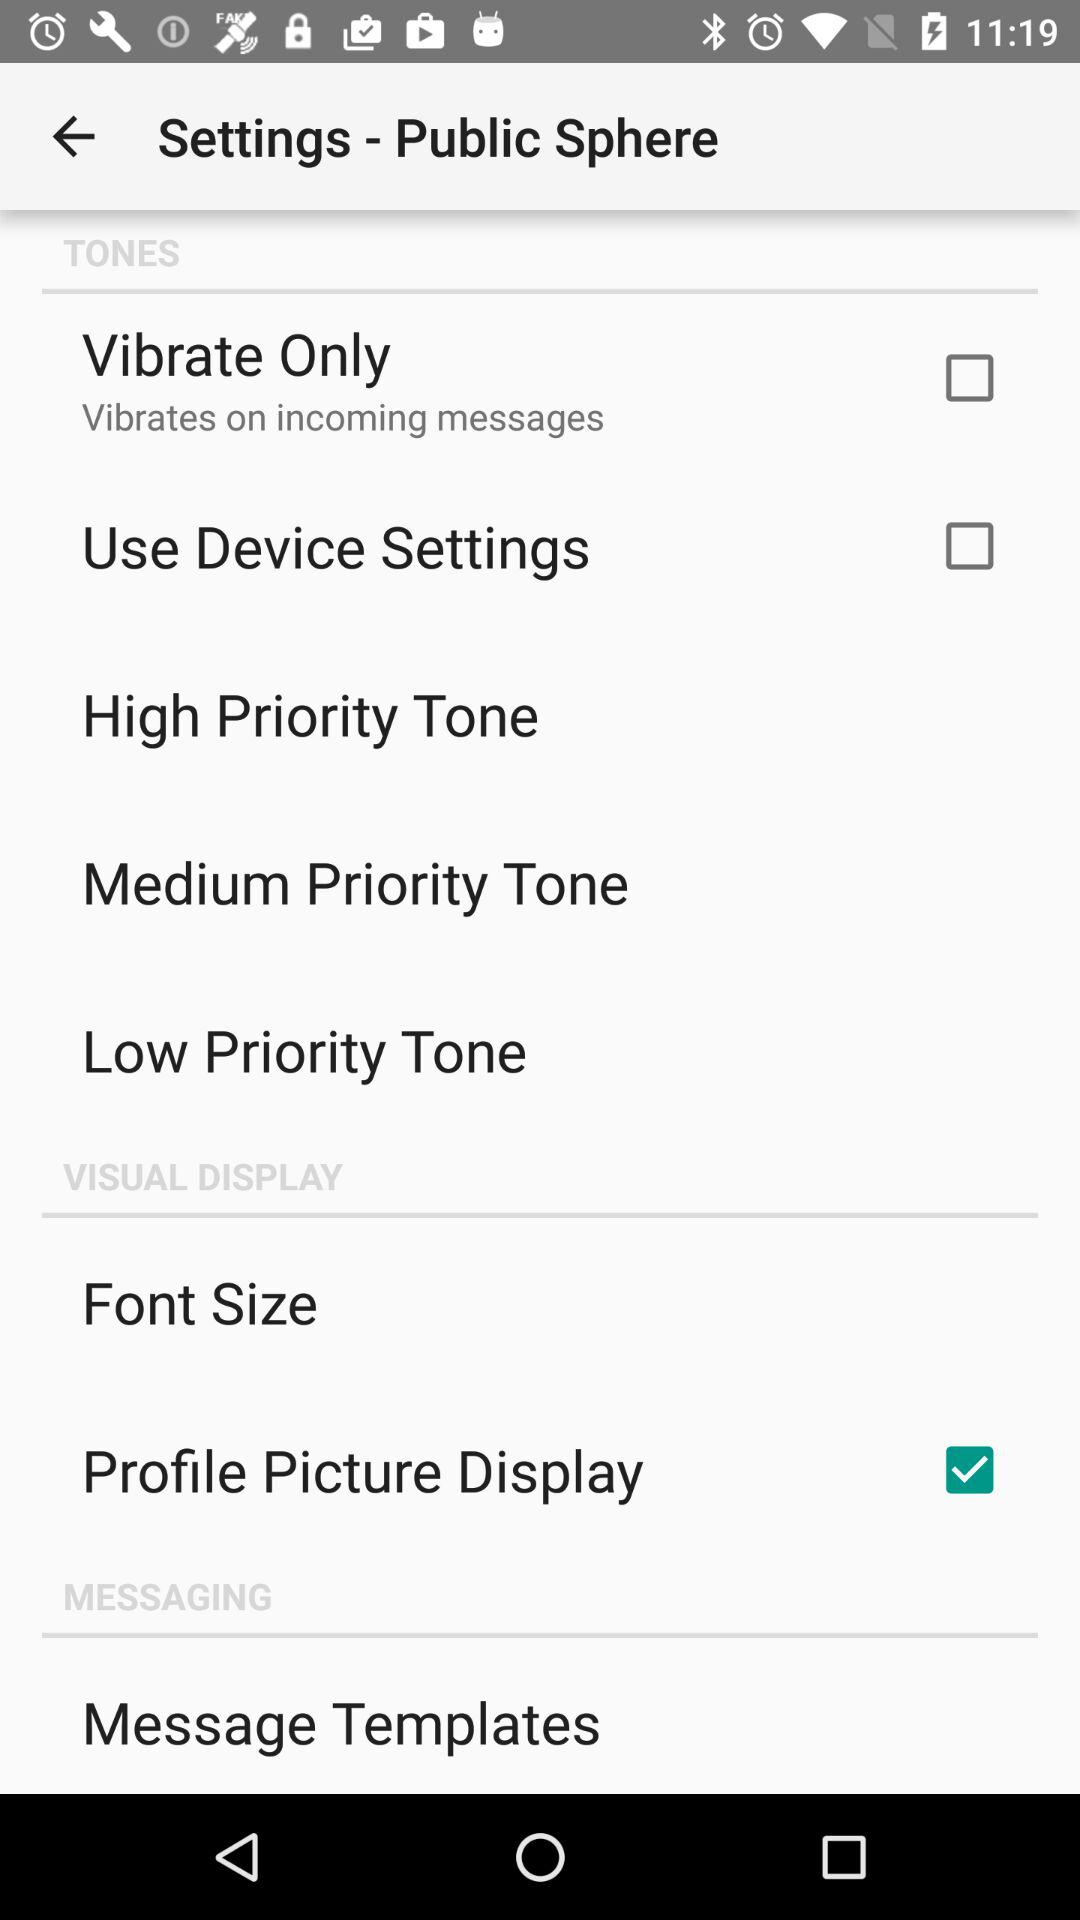What's the status of "Vibrate Only"? The status is "off". 